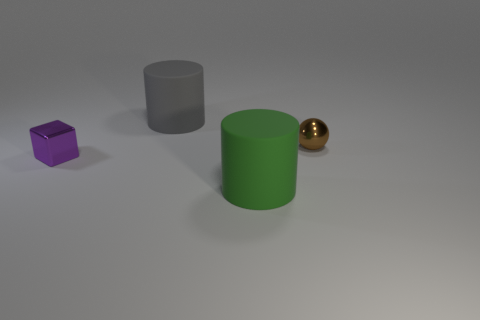Subtract 2 cylinders. How many cylinders are left? 0 Subtract all green cylinders. How many cylinders are left? 1 Add 1 large objects. How many objects exist? 5 Add 4 big cylinders. How many big cylinders are left? 6 Add 1 gray things. How many gray things exist? 2 Subtract 0 gray blocks. How many objects are left? 4 Subtract all red cylinders. Subtract all cyan balls. How many cylinders are left? 2 Subtract all blue balls. How many gray cylinders are left? 1 Subtract all tiny brown balls. Subtract all shiny blocks. How many objects are left? 2 